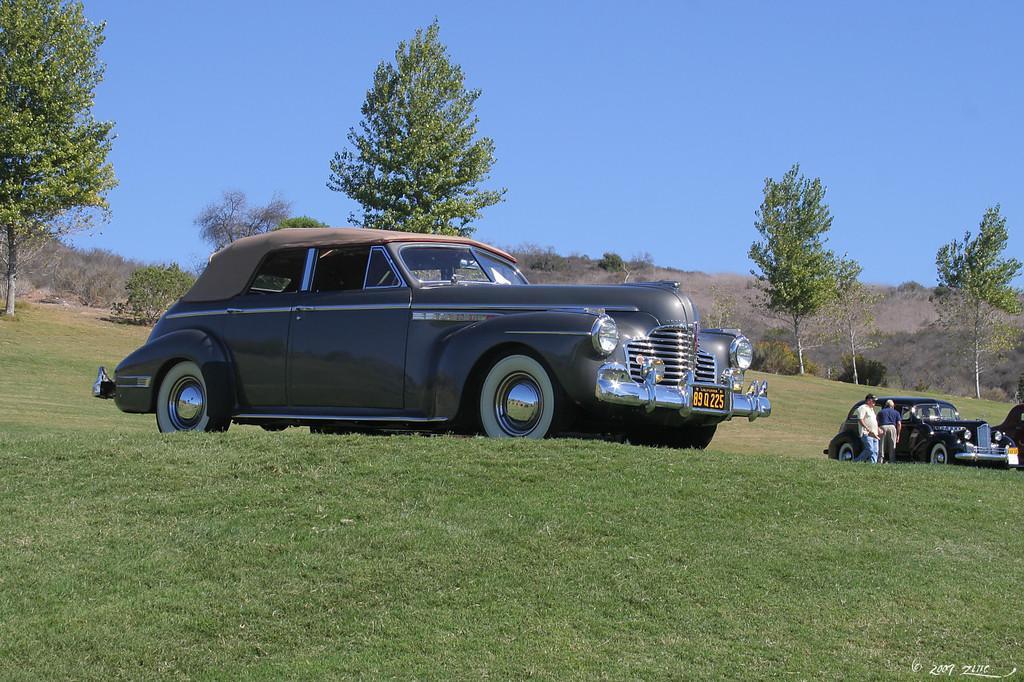Can you describe this image briefly? In this image I can see an open grass ground and on it I can see three cars. On the right side of the image I can see two persons are standing and on the bottom right side of the image I can see a watermark. In the background I can see number of trees and the sky. 